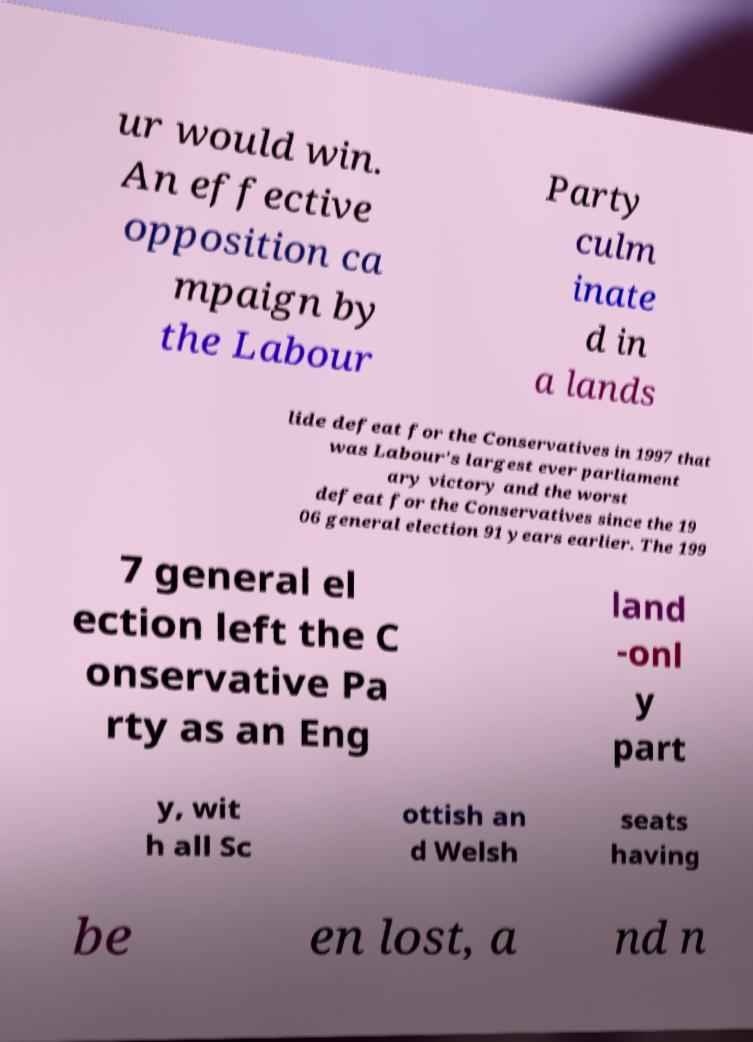Could you assist in decoding the text presented in this image and type it out clearly? ur would win. An effective opposition ca mpaign by the Labour Party culm inate d in a lands lide defeat for the Conservatives in 1997 that was Labour's largest ever parliament ary victory and the worst defeat for the Conservatives since the 19 06 general election 91 years earlier. The 199 7 general el ection left the C onservative Pa rty as an Eng land -onl y part y, wit h all Sc ottish an d Welsh seats having be en lost, a nd n 